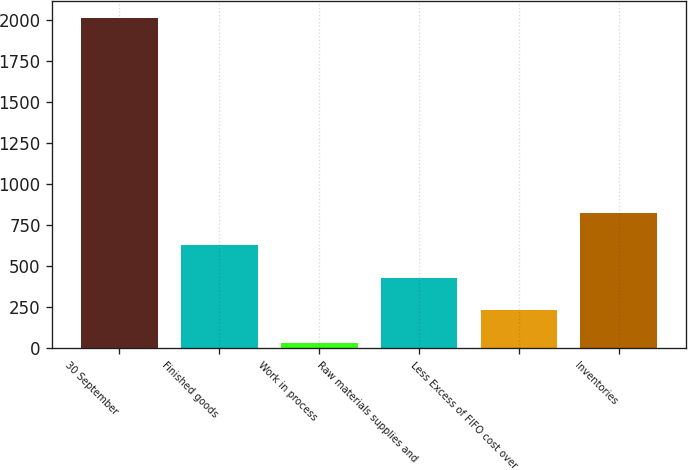<chart> <loc_0><loc_0><loc_500><loc_500><bar_chart><fcel>30 September<fcel>Finished goods<fcel>Work in process<fcel>Raw materials supplies and<fcel>Less Excess of FIFO cost over<fcel>Inventories<nl><fcel>2015<fcel>628.58<fcel>34.4<fcel>430.52<fcel>232.46<fcel>826.64<nl></chart> 